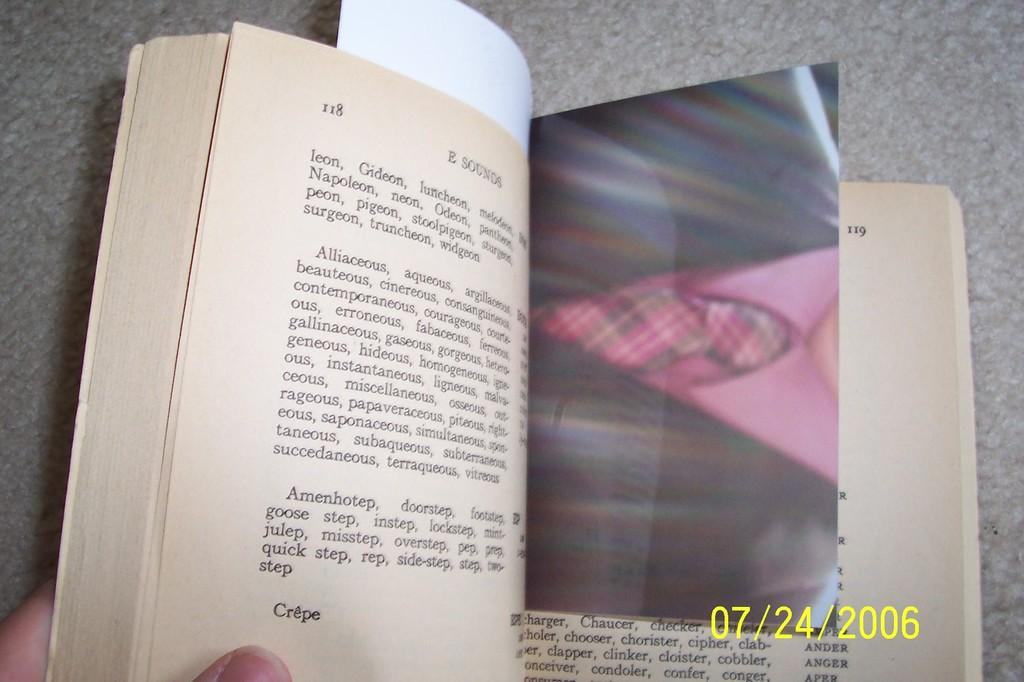<image>
Share a concise interpretation of the image provided. A picture from July of 2006 is being used as a book marker for someone. 